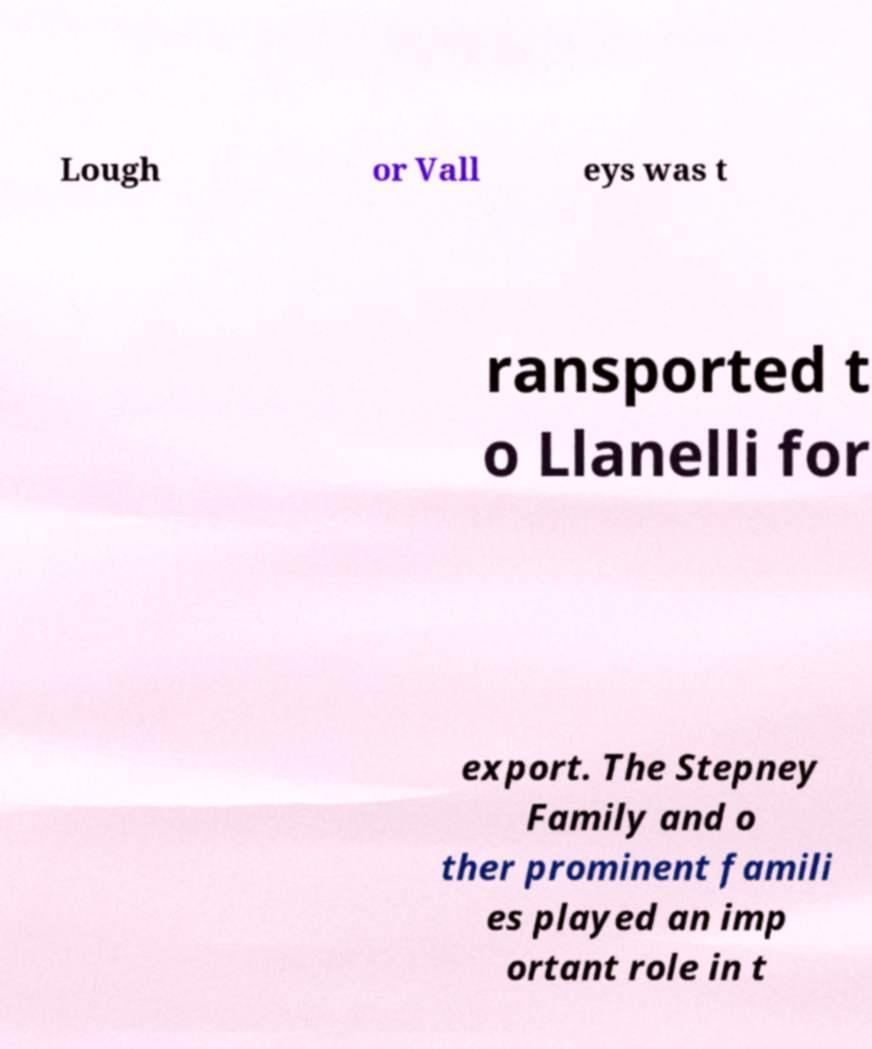Could you extract and type out the text from this image? Lough or Vall eys was t ransported t o Llanelli for export. The Stepney Family and o ther prominent famili es played an imp ortant role in t 